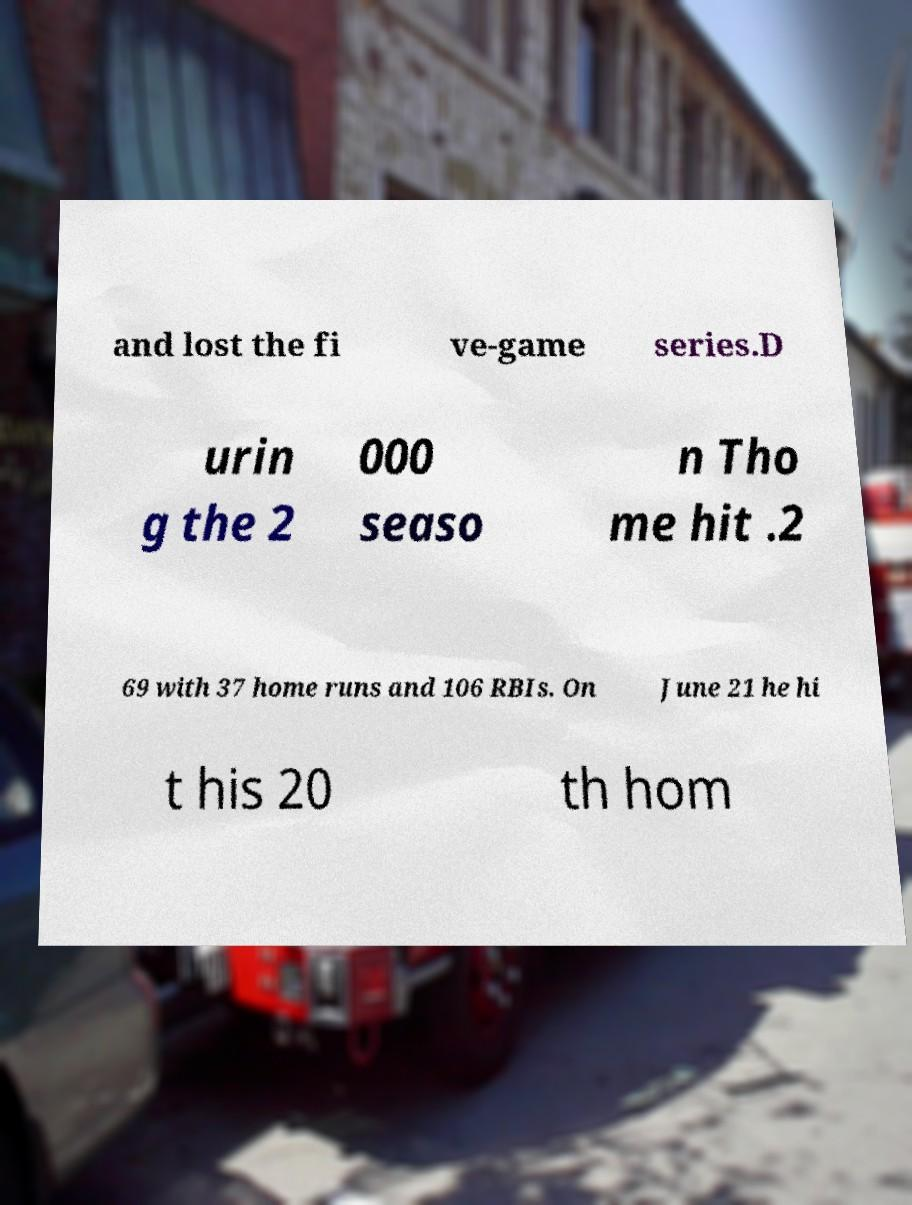There's text embedded in this image that I need extracted. Can you transcribe it verbatim? and lost the fi ve-game series.D urin g the 2 000 seaso n Tho me hit .2 69 with 37 home runs and 106 RBIs. On June 21 he hi t his 20 th hom 